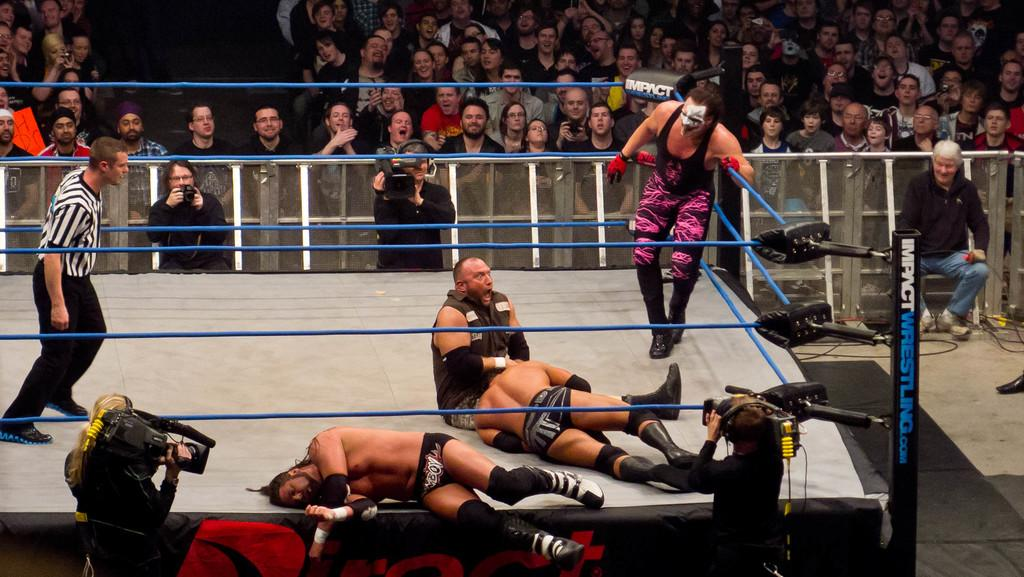<image>
Render a clear and concise summary of the photo. Sting, Bubba Ray and other wrestlers in the ring for impact wrestling 